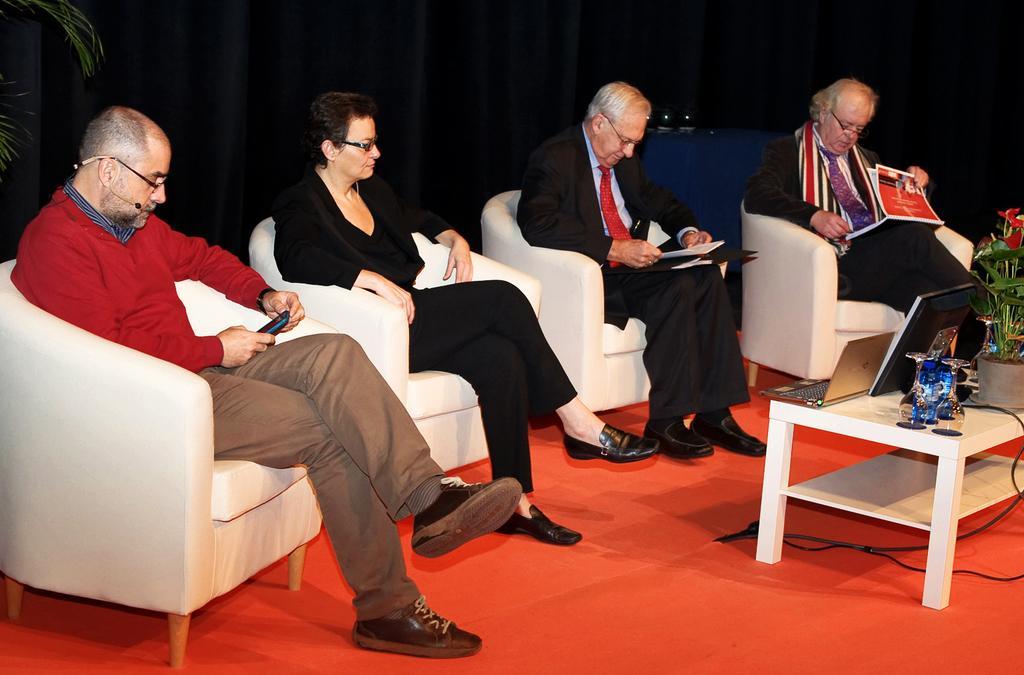In one or two sentences, can you explain what this image depicts? In this picture we can see four persons are sitting on chairs, a man on the left side is holding a mobile phone, two persons on the right side are holding books, on the right side there is a table, we can see a laptop, a plant and a monitor present on the table, it looks like a curtain in the background, on the left side there is another plant. 